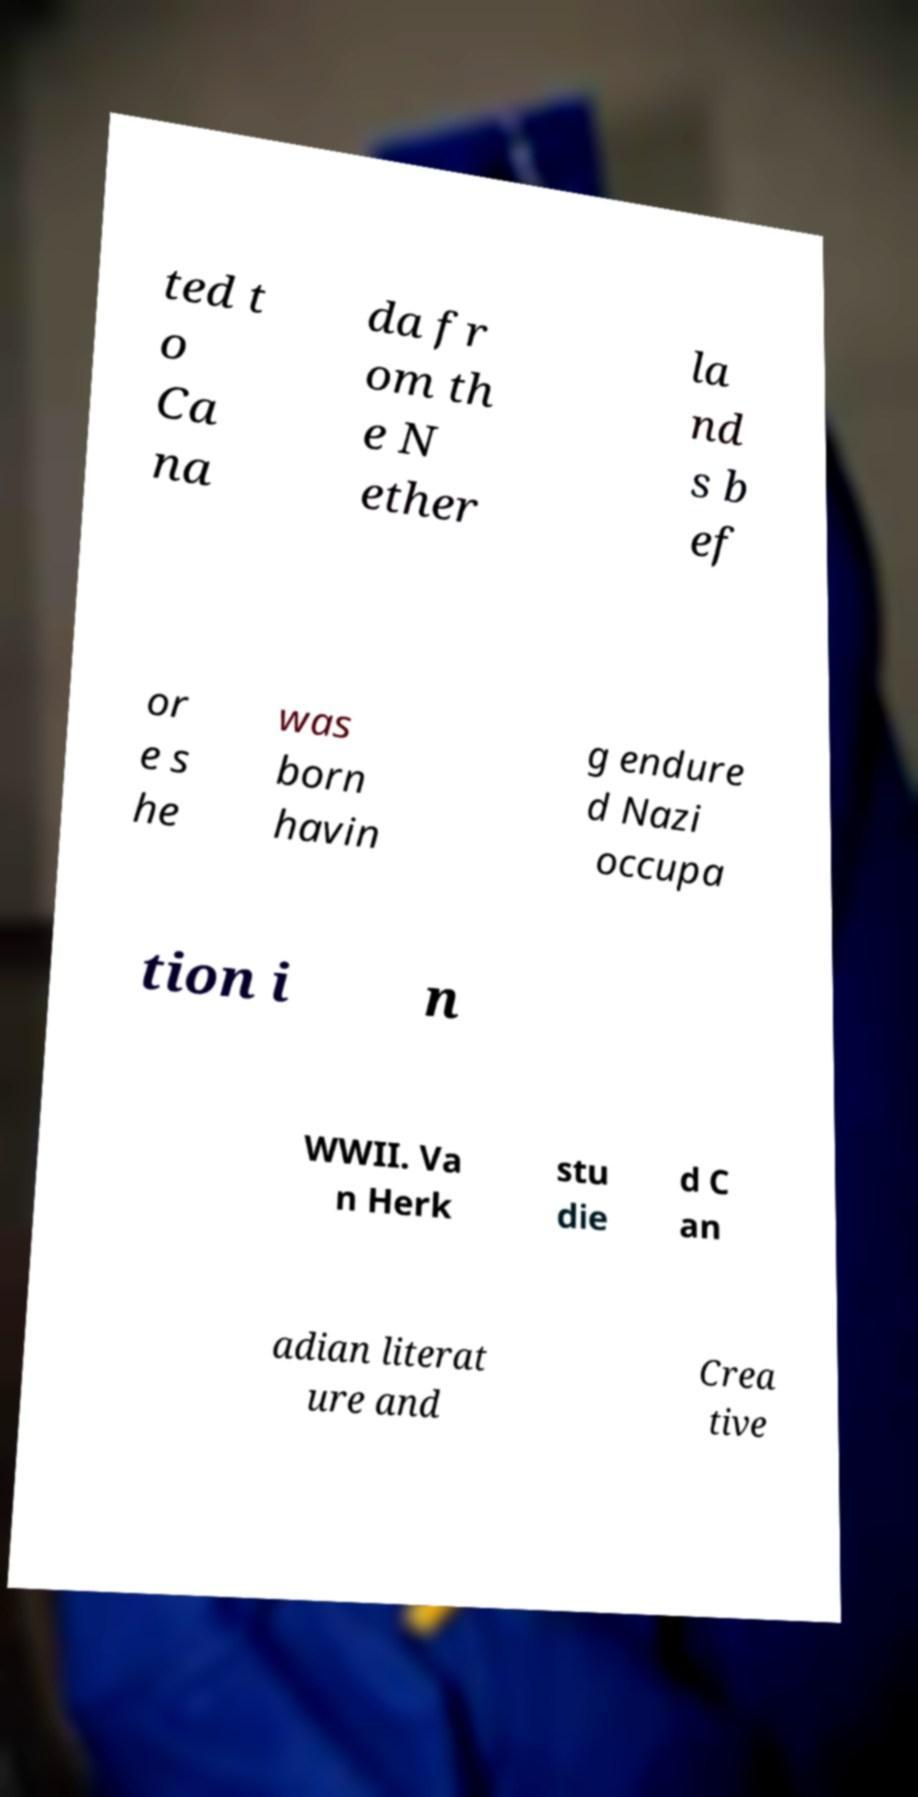Please identify and transcribe the text found in this image. ted t o Ca na da fr om th e N ether la nd s b ef or e s he was born havin g endure d Nazi occupa tion i n WWII. Va n Herk stu die d C an adian literat ure and Crea tive 